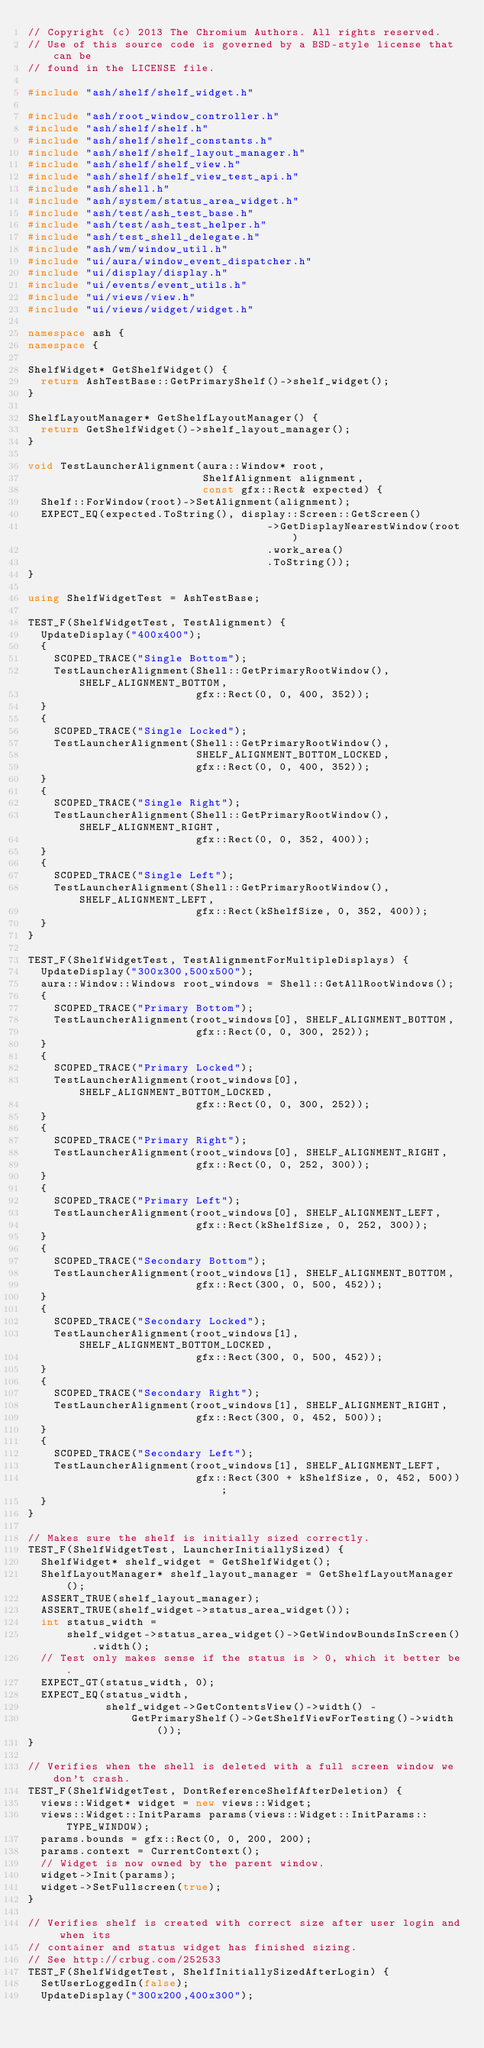Convert code to text. <code><loc_0><loc_0><loc_500><loc_500><_C++_>// Copyright (c) 2013 The Chromium Authors. All rights reserved.
// Use of this source code is governed by a BSD-style license that can be
// found in the LICENSE file.

#include "ash/shelf/shelf_widget.h"

#include "ash/root_window_controller.h"
#include "ash/shelf/shelf.h"
#include "ash/shelf/shelf_constants.h"
#include "ash/shelf/shelf_layout_manager.h"
#include "ash/shelf/shelf_view.h"
#include "ash/shelf/shelf_view_test_api.h"
#include "ash/shell.h"
#include "ash/system/status_area_widget.h"
#include "ash/test/ash_test_base.h"
#include "ash/test/ash_test_helper.h"
#include "ash/test_shell_delegate.h"
#include "ash/wm/window_util.h"
#include "ui/aura/window_event_dispatcher.h"
#include "ui/display/display.h"
#include "ui/events/event_utils.h"
#include "ui/views/view.h"
#include "ui/views/widget/widget.h"

namespace ash {
namespace {

ShelfWidget* GetShelfWidget() {
  return AshTestBase::GetPrimaryShelf()->shelf_widget();
}

ShelfLayoutManager* GetShelfLayoutManager() {
  return GetShelfWidget()->shelf_layout_manager();
}

void TestLauncherAlignment(aura::Window* root,
                           ShelfAlignment alignment,
                           const gfx::Rect& expected) {
  Shelf::ForWindow(root)->SetAlignment(alignment);
  EXPECT_EQ(expected.ToString(), display::Screen::GetScreen()
                                     ->GetDisplayNearestWindow(root)
                                     .work_area()
                                     .ToString());
}

using ShelfWidgetTest = AshTestBase;

TEST_F(ShelfWidgetTest, TestAlignment) {
  UpdateDisplay("400x400");
  {
    SCOPED_TRACE("Single Bottom");
    TestLauncherAlignment(Shell::GetPrimaryRootWindow(), SHELF_ALIGNMENT_BOTTOM,
                          gfx::Rect(0, 0, 400, 352));
  }
  {
    SCOPED_TRACE("Single Locked");
    TestLauncherAlignment(Shell::GetPrimaryRootWindow(),
                          SHELF_ALIGNMENT_BOTTOM_LOCKED,
                          gfx::Rect(0, 0, 400, 352));
  }
  {
    SCOPED_TRACE("Single Right");
    TestLauncherAlignment(Shell::GetPrimaryRootWindow(), SHELF_ALIGNMENT_RIGHT,
                          gfx::Rect(0, 0, 352, 400));
  }
  {
    SCOPED_TRACE("Single Left");
    TestLauncherAlignment(Shell::GetPrimaryRootWindow(), SHELF_ALIGNMENT_LEFT,
                          gfx::Rect(kShelfSize, 0, 352, 400));
  }
}

TEST_F(ShelfWidgetTest, TestAlignmentForMultipleDisplays) {
  UpdateDisplay("300x300,500x500");
  aura::Window::Windows root_windows = Shell::GetAllRootWindows();
  {
    SCOPED_TRACE("Primary Bottom");
    TestLauncherAlignment(root_windows[0], SHELF_ALIGNMENT_BOTTOM,
                          gfx::Rect(0, 0, 300, 252));
  }
  {
    SCOPED_TRACE("Primary Locked");
    TestLauncherAlignment(root_windows[0], SHELF_ALIGNMENT_BOTTOM_LOCKED,
                          gfx::Rect(0, 0, 300, 252));
  }
  {
    SCOPED_TRACE("Primary Right");
    TestLauncherAlignment(root_windows[0], SHELF_ALIGNMENT_RIGHT,
                          gfx::Rect(0, 0, 252, 300));
  }
  {
    SCOPED_TRACE("Primary Left");
    TestLauncherAlignment(root_windows[0], SHELF_ALIGNMENT_LEFT,
                          gfx::Rect(kShelfSize, 0, 252, 300));
  }
  {
    SCOPED_TRACE("Secondary Bottom");
    TestLauncherAlignment(root_windows[1], SHELF_ALIGNMENT_BOTTOM,
                          gfx::Rect(300, 0, 500, 452));
  }
  {
    SCOPED_TRACE("Secondary Locked");
    TestLauncherAlignment(root_windows[1], SHELF_ALIGNMENT_BOTTOM_LOCKED,
                          gfx::Rect(300, 0, 500, 452));
  }
  {
    SCOPED_TRACE("Secondary Right");
    TestLauncherAlignment(root_windows[1], SHELF_ALIGNMENT_RIGHT,
                          gfx::Rect(300, 0, 452, 500));
  }
  {
    SCOPED_TRACE("Secondary Left");
    TestLauncherAlignment(root_windows[1], SHELF_ALIGNMENT_LEFT,
                          gfx::Rect(300 + kShelfSize, 0, 452, 500));
  }
}

// Makes sure the shelf is initially sized correctly.
TEST_F(ShelfWidgetTest, LauncherInitiallySized) {
  ShelfWidget* shelf_widget = GetShelfWidget();
  ShelfLayoutManager* shelf_layout_manager = GetShelfLayoutManager();
  ASSERT_TRUE(shelf_layout_manager);
  ASSERT_TRUE(shelf_widget->status_area_widget());
  int status_width =
      shelf_widget->status_area_widget()->GetWindowBoundsInScreen().width();
  // Test only makes sense if the status is > 0, which it better be.
  EXPECT_GT(status_width, 0);
  EXPECT_EQ(status_width,
            shelf_widget->GetContentsView()->width() -
                GetPrimaryShelf()->GetShelfViewForTesting()->width());
}

// Verifies when the shell is deleted with a full screen window we don't crash.
TEST_F(ShelfWidgetTest, DontReferenceShelfAfterDeletion) {
  views::Widget* widget = new views::Widget;
  views::Widget::InitParams params(views::Widget::InitParams::TYPE_WINDOW);
  params.bounds = gfx::Rect(0, 0, 200, 200);
  params.context = CurrentContext();
  // Widget is now owned by the parent window.
  widget->Init(params);
  widget->SetFullscreen(true);
}

// Verifies shelf is created with correct size after user login and when its
// container and status widget has finished sizing.
// See http://crbug.com/252533
TEST_F(ShelfWidgetTest, ShelfInitiallySizedAfterLogin) {
  SetUserLoggedIn(false);
  UpdateDisplay("300x200,400x300");
</code> 